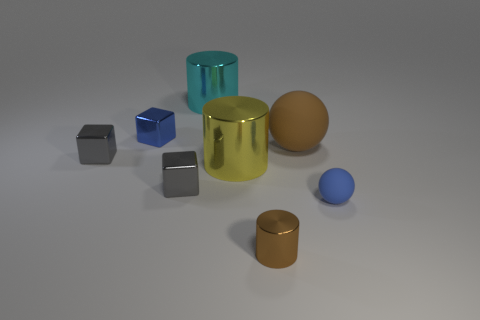There is a small blue thing that is right of the large shiny cylinder that is to the left of the big yellow cylinder; what is it made of?
Offer a terse response. Rubber. There is a brown object in front of the yellow object; is its shape the same as the rubber thing that is on the left side of the small sphere?
Provide a short and direct response. No. There is a object that is both left of the tiny brown shiny cylinder and in front of the yellow cylinder; what size is it?
Ensure brevity in your answer.  Small. How many other objects are the same color as the small rubber ball?
Give a very brief answer. 1. Is the small blue thing behind the large yellow object made of the same material as the brown cylinder?
Your answer should be compact. Yes. Is the number of tiny brown objects on the right side of the blue matte object less than the number of blue objects in front of the big brown thing?
Keep it short and to the point. Yes. What is the material of the tiny thing that is the same color as the big rubber ball?
Your answer should be compact. Metal. There is a tiny gray block on the left side of the block that is right of the blue shiny thing; what number of big shiny things are to the left of it?
Your answer should be compact. 0. There is a tiny blue rubber object; what number of big matte objects are in front of it?
Ensure brevity in your answer.  0. How many small gray cubes are the same material as the big yellow cylinder?
Offer a very short reply. 2. 